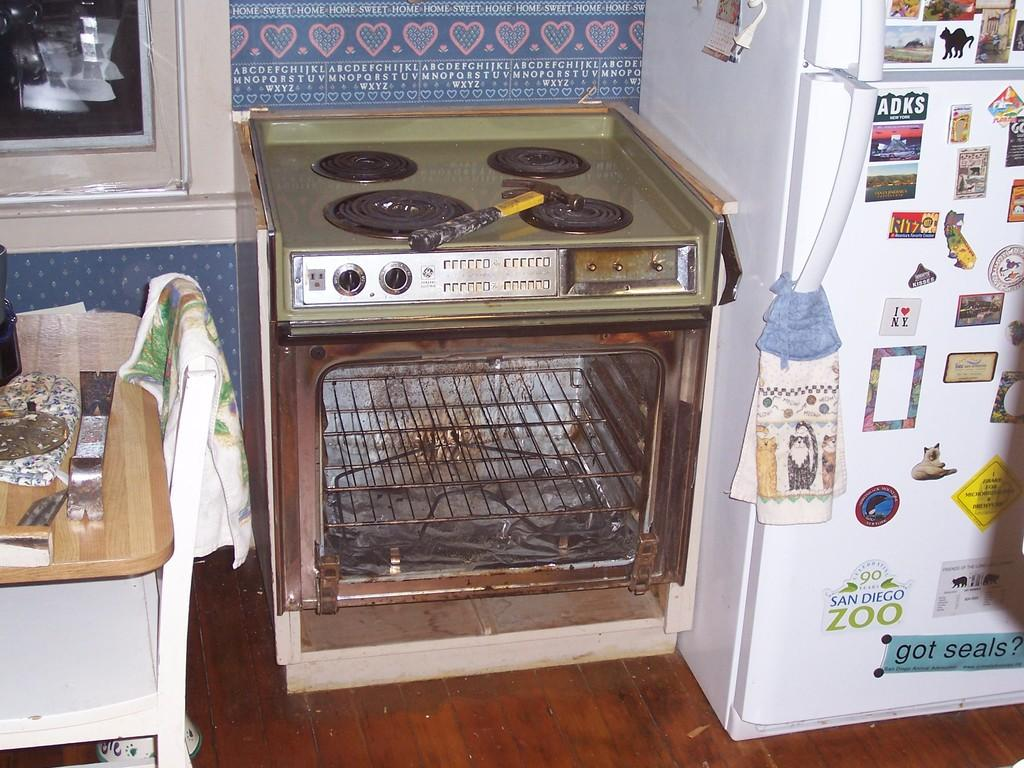<image>
Offer a succinct explanation of the picture presented. someone's broken messy GE stove with the refrigerator next to it having advertisements on it from ADKS, San Diego Zoo and Ritz. 